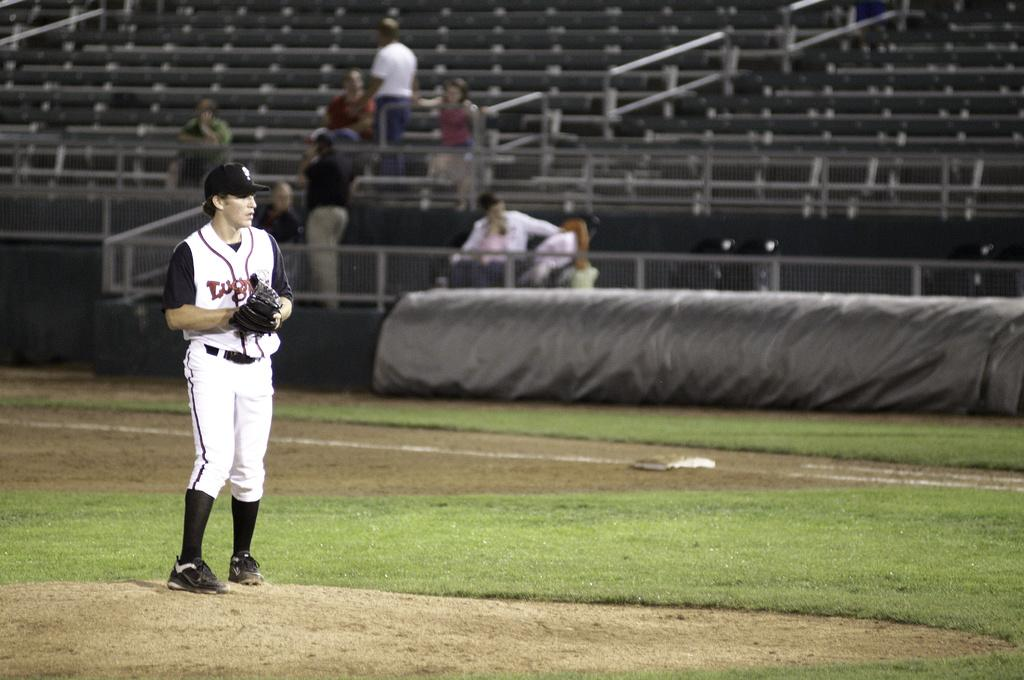What is the main subject of the image? There is a player standing on the ground. What can be seen in the background of the image? There are people sitting on chairs and two persons standing in the background. Can you see any babies playing in the ocean in the image? There is no ocean or babies present in the image. 